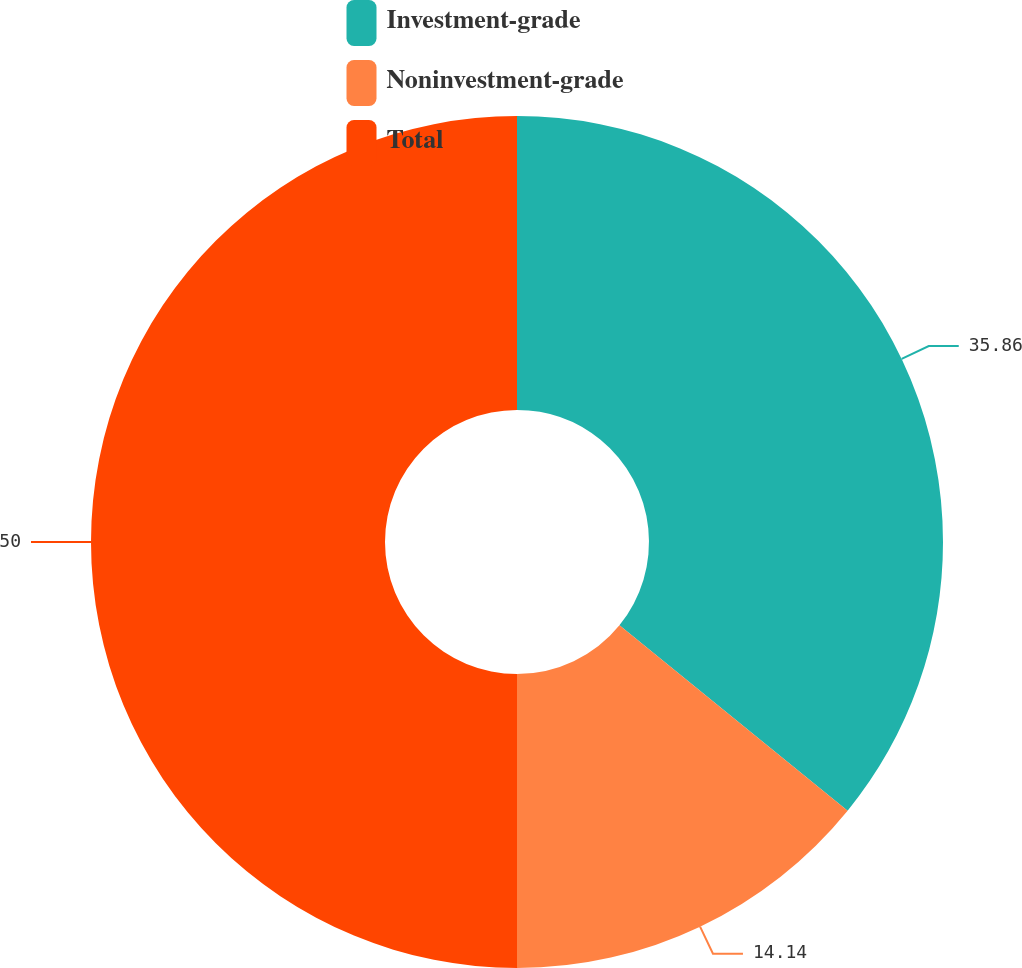Convert chart to OTSL. <chart><loc_0><loc_0><loc_500><loc_500><pie_chart><fcel>Investment-grade<fcel>Noninvestment-grade<fcel>Total<nl><fcel>35.86%<fcel>14.14%<fcel>50.0%<nl></chart> 